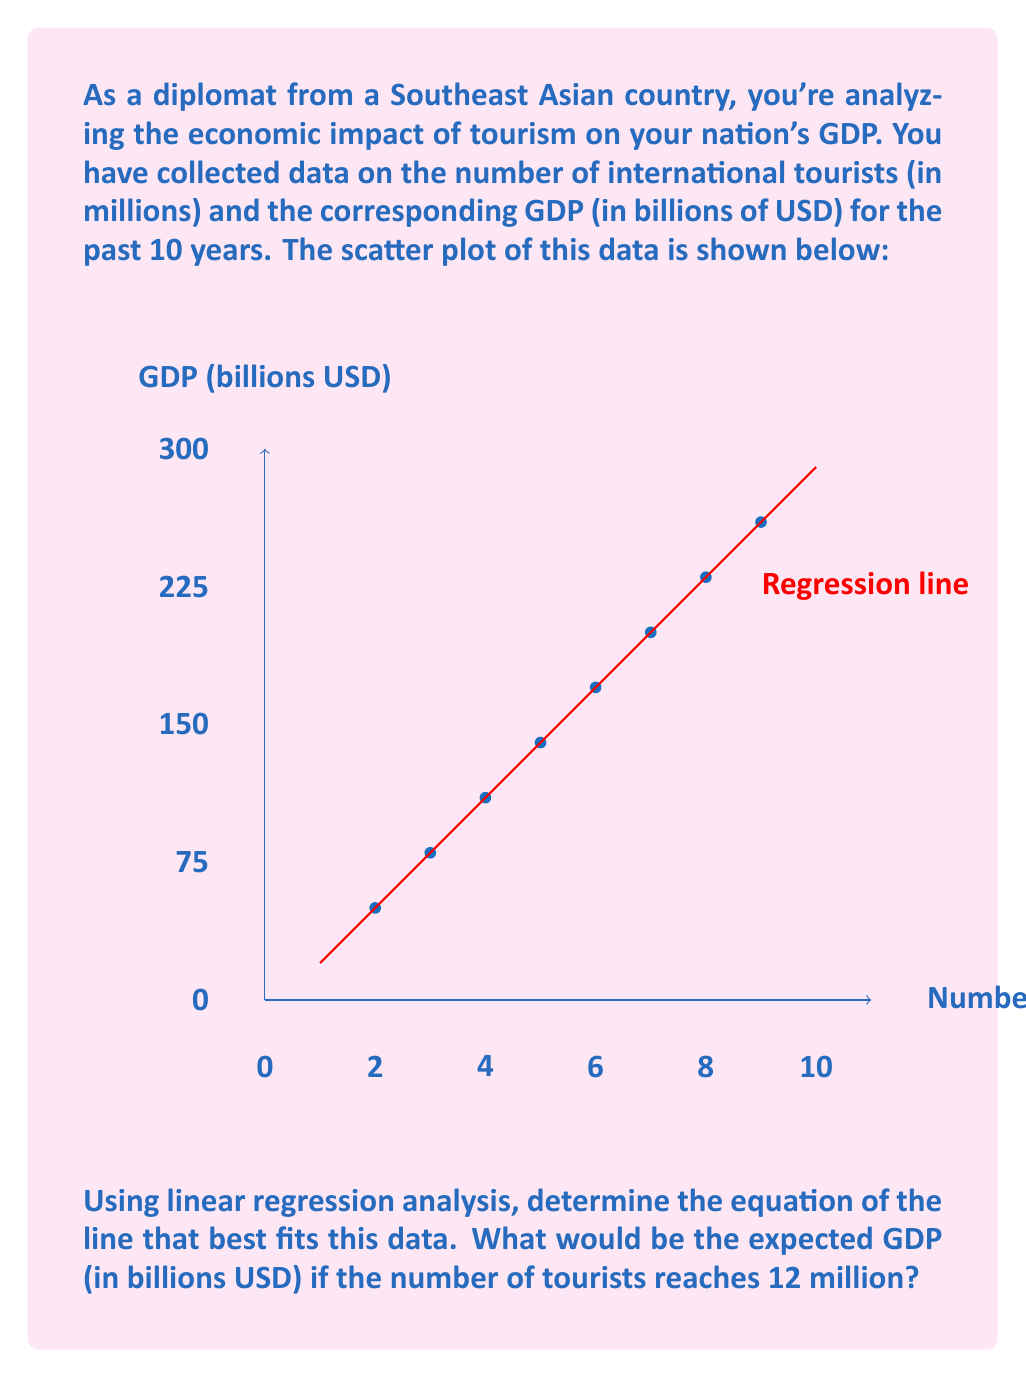Can you solve this math problem? To solve this problem, we'll follow these steps:

1) From the scatter plot, we can see that there's a strong positive linear relationship between the number of tourists and GDP.

2) The equation of a linear regression line is of the form:
   $$y = mx + b$$
   where $y$ is GDP, $x$ is the number of tourists, $m$ is the slope, and $b$ is the y-intercept.

3) From the graph, we can estimate the slope and y-intercept:
   - The line appears to start at about (0, 20), so $b \approx 20$
   - The line rises about 270 billion over 9 million tourists, so $m \approx 270/9 = 30$

4) Therefore, the estimated equation of the regression line is:
   $$y = 30x + 20$$

5) To find the expected GDP when tourists reach 12 million, we substitute $x = 12$ into our equation:
   $$y = 30(12) + 20 = 360 + 20 = 380$$

Thus, the expected GDP when tourists reach 12 million is approximately 380 billion USD.
Answer: $380 billion USD 